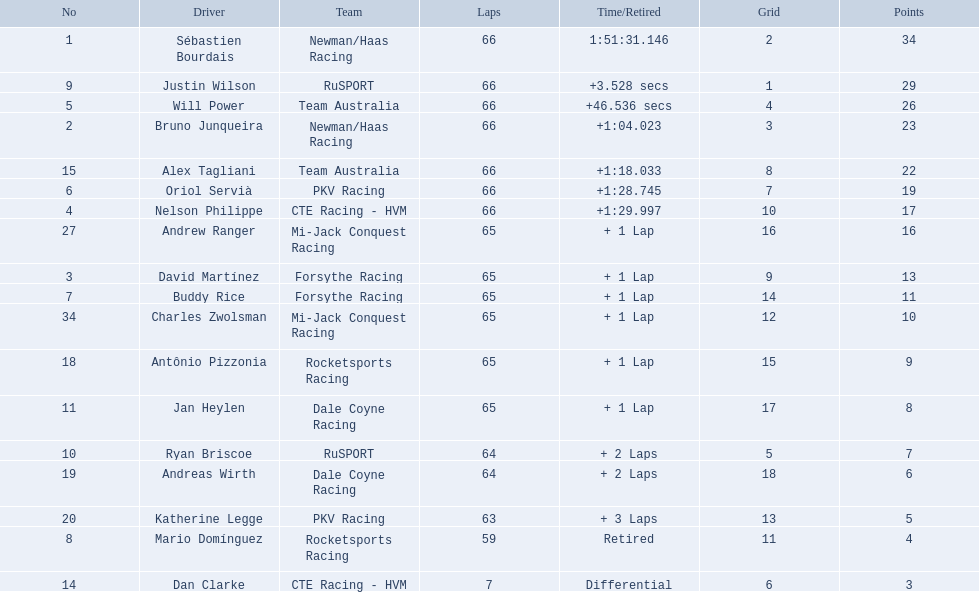How many points did first place receive? 34. How many did last place receive? 3. I'm looking to parse the entire table for insights. Could you assist me with that? {'header': ['No', 'Driver', 'Team', 'Laps', 'Time/Retired', 'Grid', 'Points'], 'rows': [['1', 'Sébastien Bourdais', 'Newman/Haas Racing', '66', '1:51:31.146', '2', '34'], ['9', 'Justin Wilson', 'RuSPORT', '66', '+3.528 secs', '1', '29'], ['5', 'Will Power', 'Team Australia', '66', '+46.536 secs', '4', '26'], ['2', 'Bruno Junqueira', 'Newman/Haas Racing', '66', '+1:04.023', '3', '23'], ['15', 'Alex Tagliani', 'Team Australia', '66', '+1:18.033', '8', '22'], ['6', 'Oriol Servià', 'PKV Racing', '66', '+1:28.745', '7', '19'], ['4', 'Nelson Philippe', 'CTE Racing - HVM', '66', '+1:29.997', '10', '17'], ['27', 'Andrew Ranger', 'Mi-Jack Conquest Racing', '65', '+ 1 Lap', '16', '16'], ['3', 'David Martínez', 'Forsythe Racing', '65', '+ 1 Lap', '9', '13'], ['7', 'Buddy Rice', 'Forsythe Racing', '65', '+ 1 Lap', '14', '11'], ['34', 'Charles Zwolsman', 'Mi-Jack Conquest Racing', '65', '+ 1 Lap', '12', '10'], ['18', 'Antônio Pizzonia', 'Rocketsports Racing', '65', '+ 1 Lap', '15', '9'], ['11', 'Jan Heylen', 'Dale Coyne Racing', '65', '+ 1 Lap', '17', '8'], ['10', 'Ryan Briscoe', 'RuSPORT', '64', '+ 2 Laps', '5', '7'], ['19', 'Andreas Wirth', 'Dale Coyne Racing', '64', '+ 2 Laps', '18', '6'], ['20', 'Katherine Legge', 'PKV Racing', '63', '+ 3 Laps', '13', '5'], ['8', 'Mario Domínguez', 'Rocketsports Racing', '59', 'Retired', '11', '4'], ['14', 'Dan Clarke', 'CTE Racing - HVM', '7', 'Differential', '6', '3']]} Who was the recipient of these last place points? Dan Clarke. 